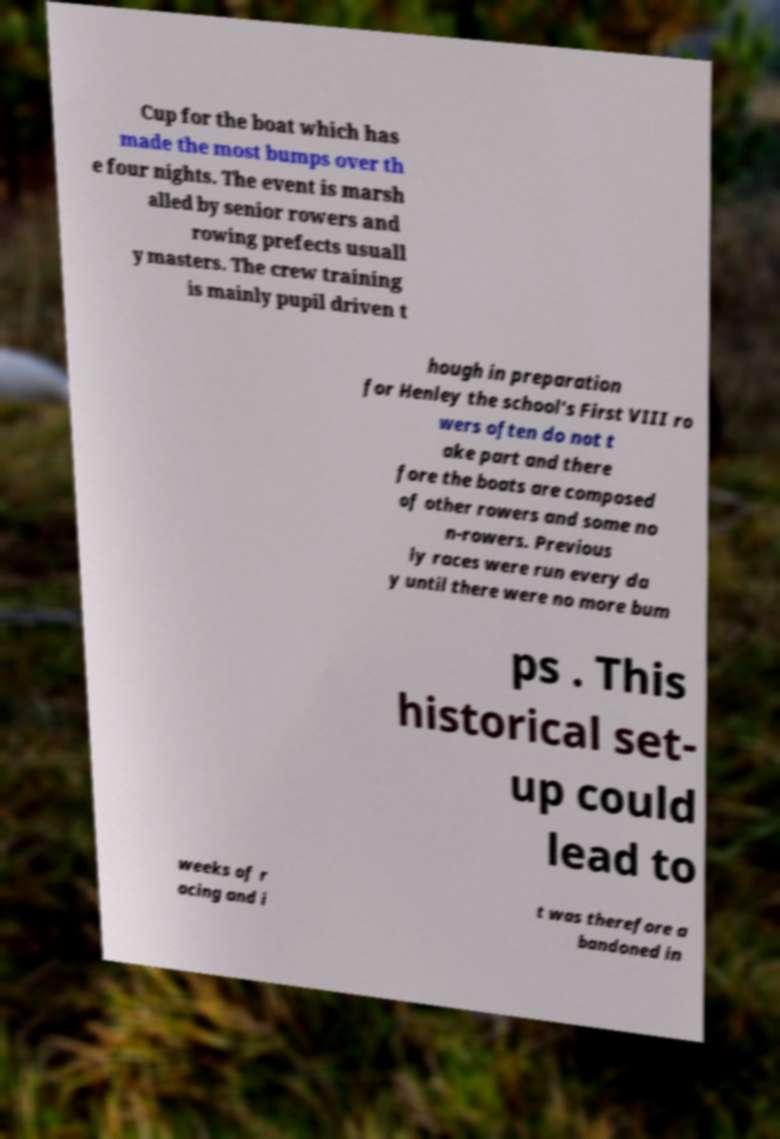Could you assist in decoding the text presented in this image and type it out clearly? Cup for the boat which has made the most bumps over th e four nights. The event is marsh alled by senior rowers and rowing prefects usuall y masters. The crew training is mainly pupil driven t hough in preparation for Henley the school's First VIII ro wers often do not t ake part and there fore the boats are composed of other rowers and some no n-rowers. Previous ly races were run every da y until there were no more bum ps . This historical set- up could lead to weeks of r acing and i t was therefore a bandoned in 